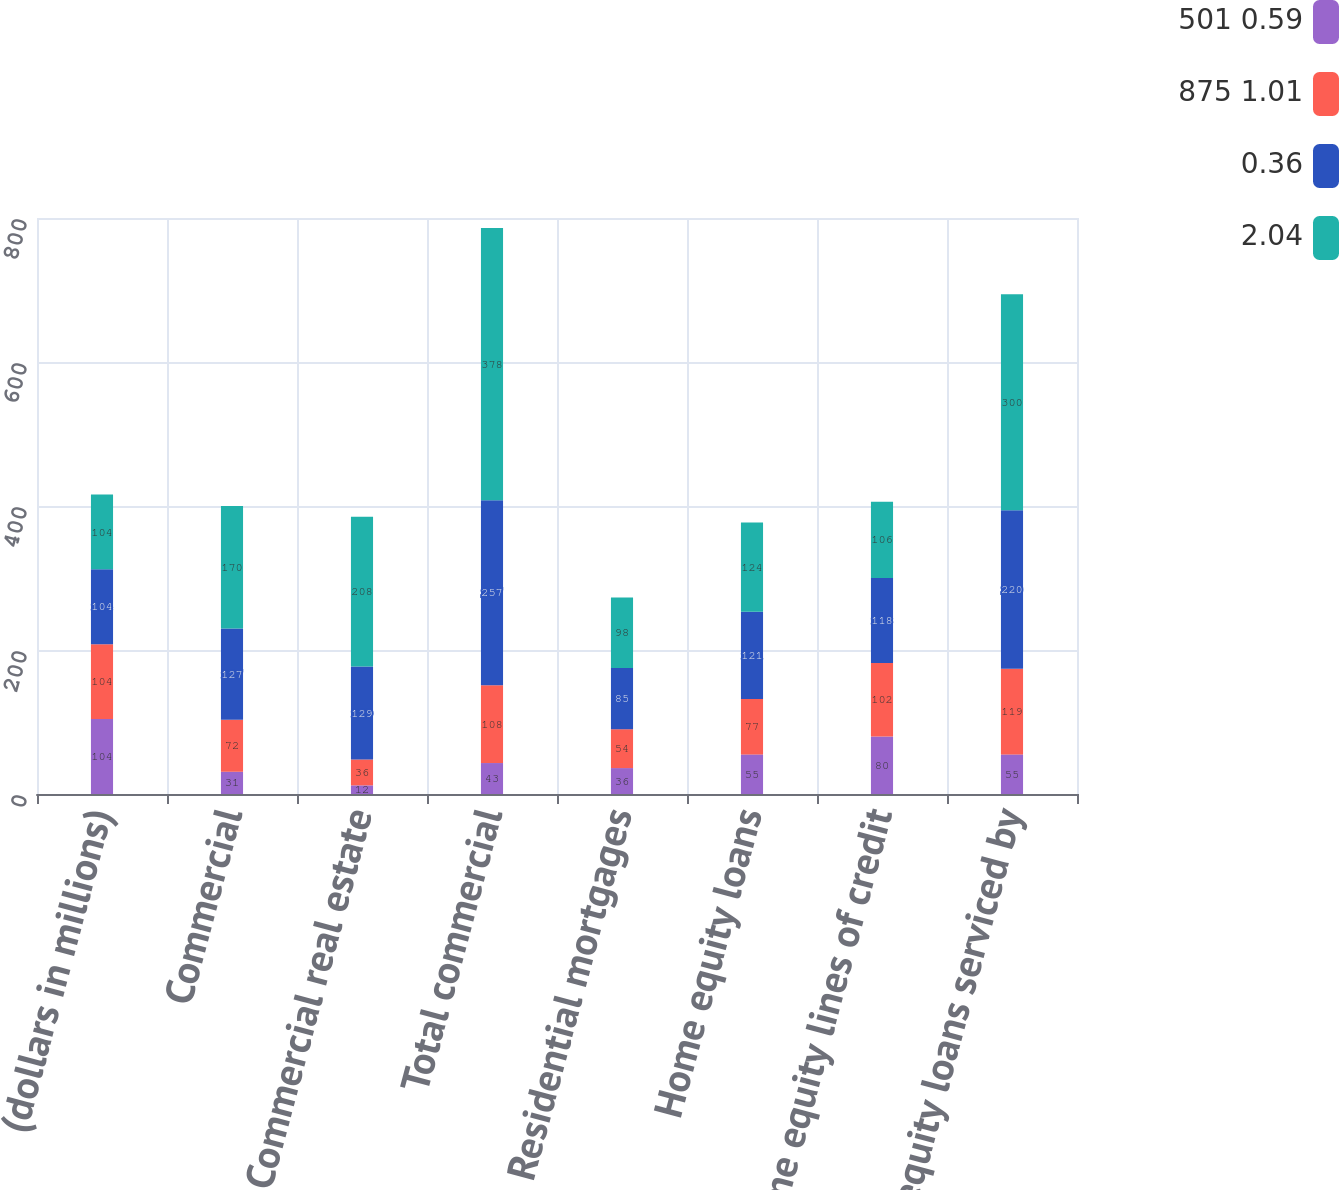Convert chart to OTSL. <chart><loc_0><loc_0><loc_500><loc_500><stacked_bar_chart><ecel><fcel>(dollars in millions)<fcel>Commercial<fcel>Commercial real estate<fcel>Total commercial<fcel>Residential mortgages<fcel>Home equity loans<fcel>Home equity lines of credit<fcel>Home equity loans serviced by<nl><fcel>501 0.59<fcel>104<fcel>31<fcel>12<fcel>43<fcel>36<fcel>55<fcel>80<fcel>55<nl><fcel>875 1.01<fcel>104<fcel>72<fcel>36<fcel>108<fcel>54<fcel>77<fcel>102<fcel>119<nl><fcel>0.36<fcel>104<fcel>127<fcel>129<fcel>257<fcel>85<fcel>121<fcel>118<fcel>220<nl><fcel>2.04<fcel>104<fcel>170<fcel>208<fcel>378<fcel>98<fcel>124<fcel>106<fcel>300<nl></chart> 